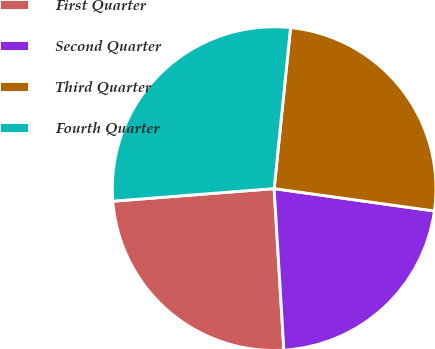<chart> <loc_0><loc_0><loc_500><loc_500><pie_chart><fcel>First Quarter<fcel>Second Quarter<fcel>Third Quarter<fcel>Fourth Quarter<nl><fcel>24.72%<fcel>21.83%<fcel>25.59%<fcel>27.85%<nl></chart> 